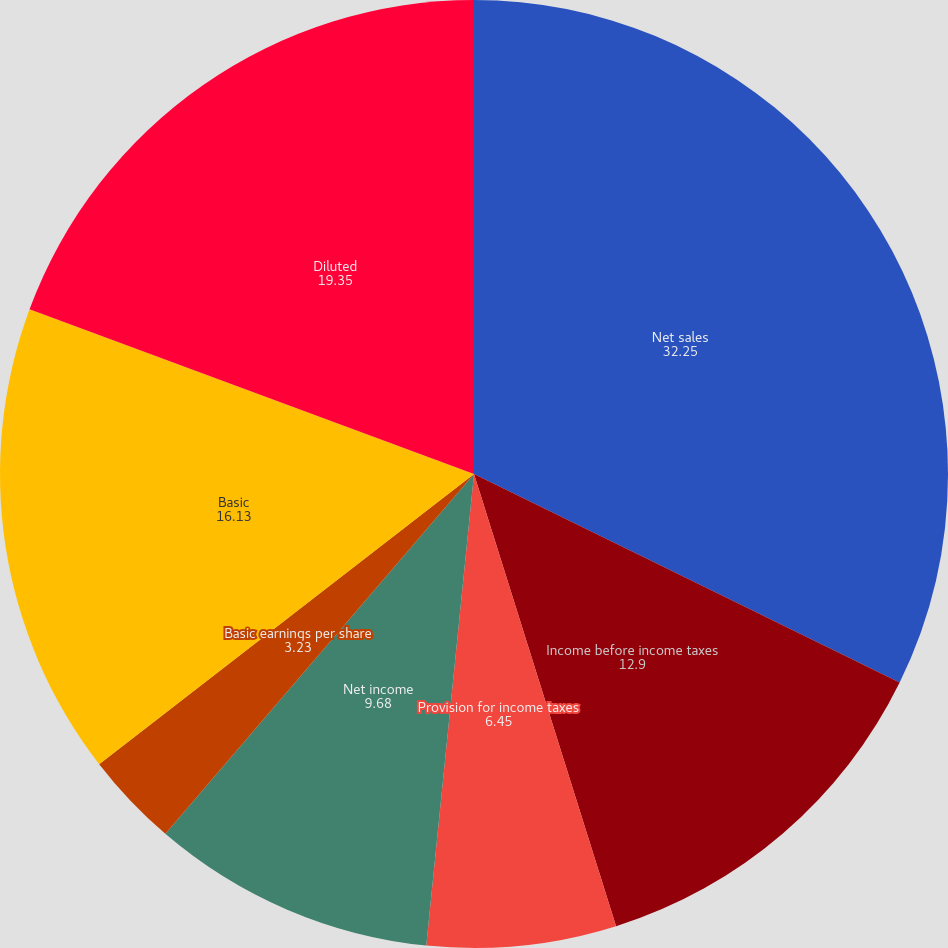<chart> <loc_0><loc_0><loc_500><loc_500><pie_chart><fcel>Net sales<fcel>Income before income taxes<fcel>Provision for income taxes<fcel>Net income<fcel>Basic earnings per share<fcel>Diluted earnings per share<fcel>Basic<fcel>Diluted<nl><fcel>32.25%<fcel>12.9%<fcel>6.45%<fcel>9.68%<fcel>3.23%<fcel>0.0%<fcel>16.13%<fcel>19.35%<nl></chart> 